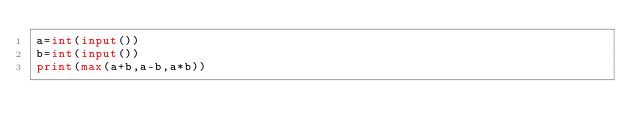Convert code to text. <code><loc_0><loc_0><loc_500><loc_500><_Python_>a=int(input())
b=int(input())
print(max(a+b,a-b,a*b))
</code> 